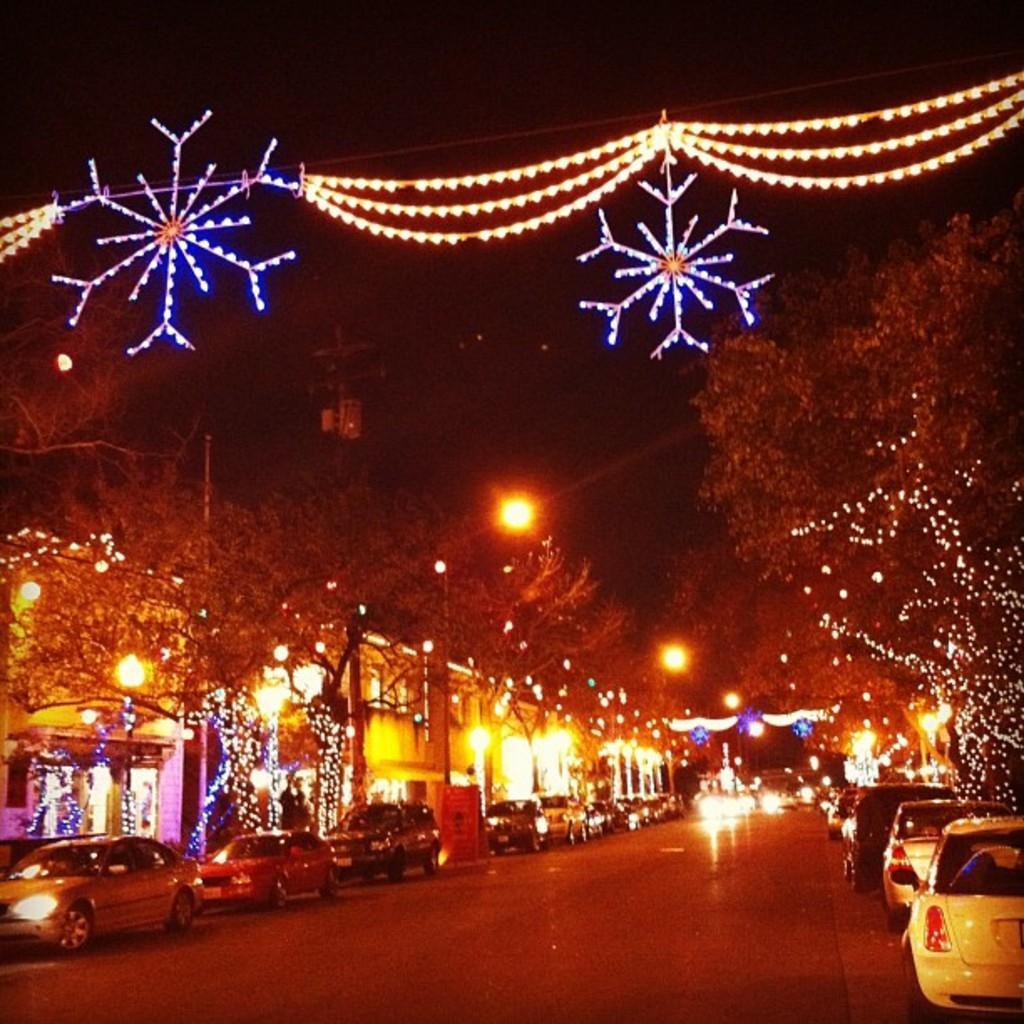Can you describe this image briefly? This picture is clicked outside. We can see the group of cats seems to be parked on the ground. At the top we can see the decoration lights are hanging on the rope. In the background there is a sky and we can see the street lights, trees and buildings. 